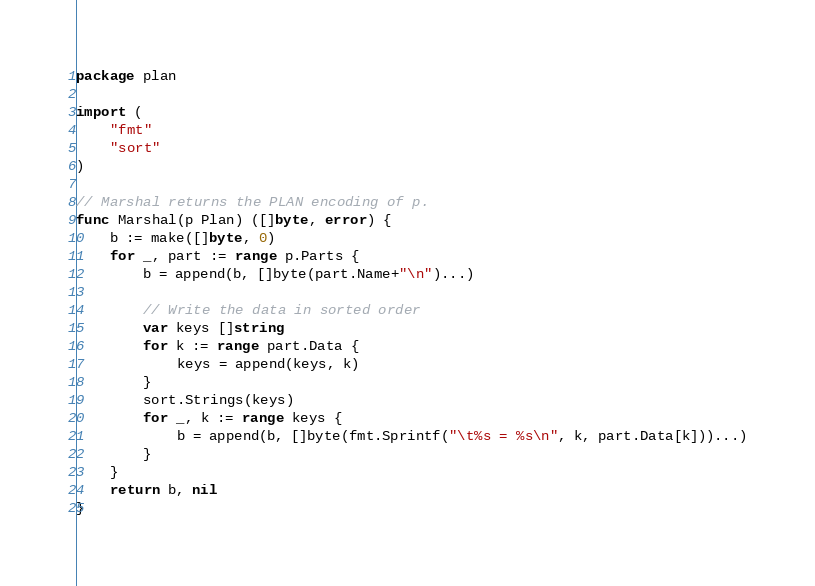<code> <loc_0><loc_0><loc_500><loc_500><_Go_>package plan

import (
	"fmt"
	"sort"
)

// Marshal returns the PLAN encoding of p.
func Marshal(p Plan) ([]byte, error) {
	b := make([]byte, 0)
	for _, part := range p.Parts {
		b = append(b, []byte(part.Name+"\n")...)

		// Write the data in sorted order
		var keys []string
		for k := range part.Data {
			keys = append(keys, k)
		}
		sort.Strings(keys)
		for _, k := range keys {
			b = append(b, []byte(fmt.Sprintf("\t%s = %s\n", k, part.Data[k]))...)
		}
	}
	return b, nil
}
</code> 